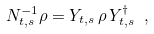<formula> <loc_0><loc_0><loc_500><loc_500>N _ { t , s } ^ { - 1 } \rho = Y _ { t , s } \, \rho \, Y _ { t , s } ^ { \dagger } \ ,</formula> 